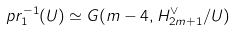Convert formula to latex. <formula><loc_0><loc_0><loc_500><loc_500>p r _ { 1 } ^ { - 1 } ( U ) \simeq G ( m - 4 , H ^ { \vee } _ { 2 m + 1 } / U )</formula> 